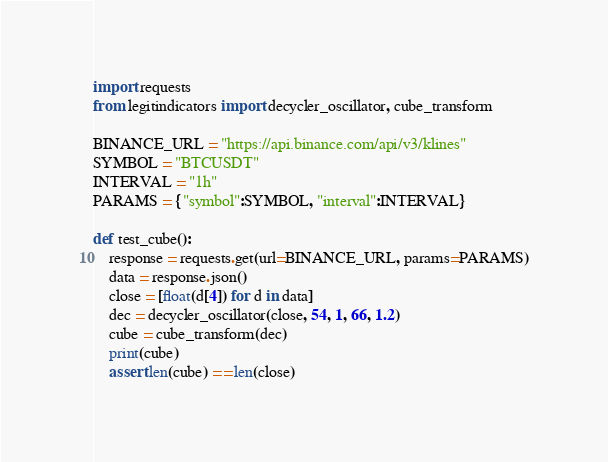<code> <loc_0><loc_0><loc_500><loc_500><_Python_>import requests
from legitindicators import decycler_oscillator, cube_transform

BINANCE_URL = "https://api.binance.com/api/v3/klines"
SYMBOL = "BTCUSDT"
INTERVAL = "1h"
PARAMS = {"symbol":SYMBOL, "interval":INTERVAL}

def test_cube():
    response = requests.get(url=BINANCE_URL, params=PARAMS)
    data = response.json()
    close = [float(d[4]) for d in data]
    dec = decycler_oscillator(close, 54, 1, 66, 1.2)
    cube = cube_transform(dec)
    print(cube)
    assert len(cube) == len(close)
</code> 